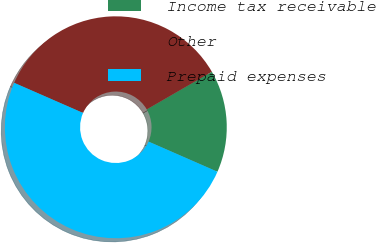Convert chart to OTSL. <chart><loc_0><loc_0><loc_500><loc_500><pie_chart><fcel>Income tax receivable<fcel>Other<fcel>Prepaid expenses<nl><fcel>14.9%<fcel>35.1%<fcel>50.0%<nl></chart> 